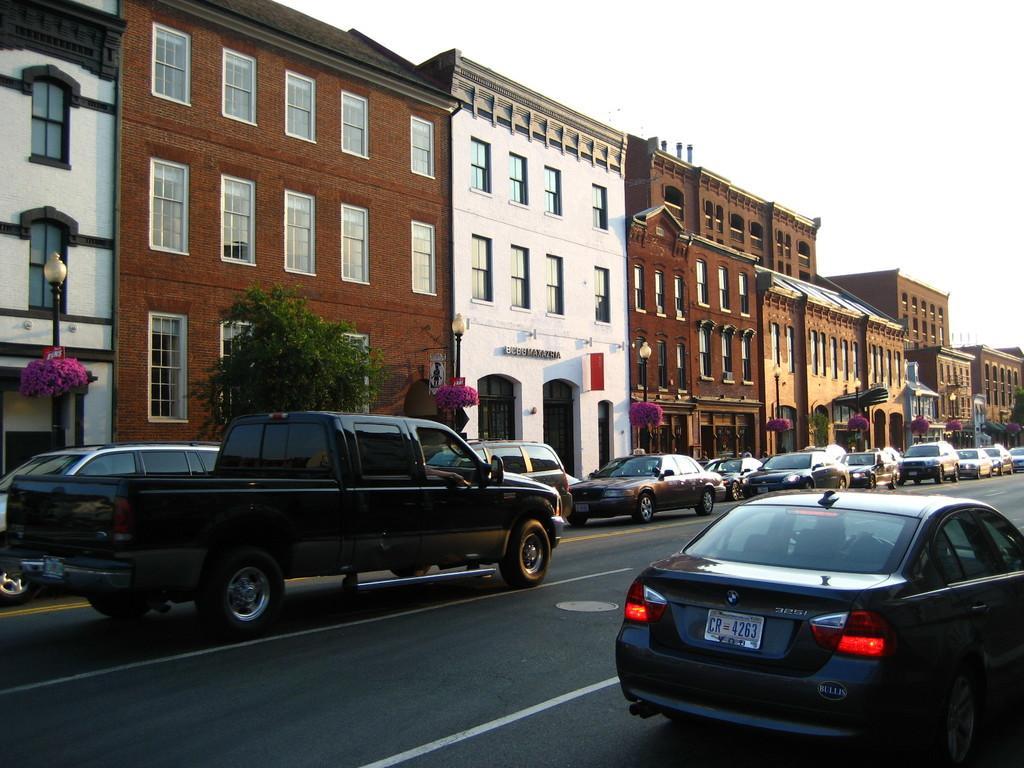In one or two sentences, can you explain what this image depicts? At the bottom of the image we can see cars on the road. In the background we can see trees, buildings and sky. 